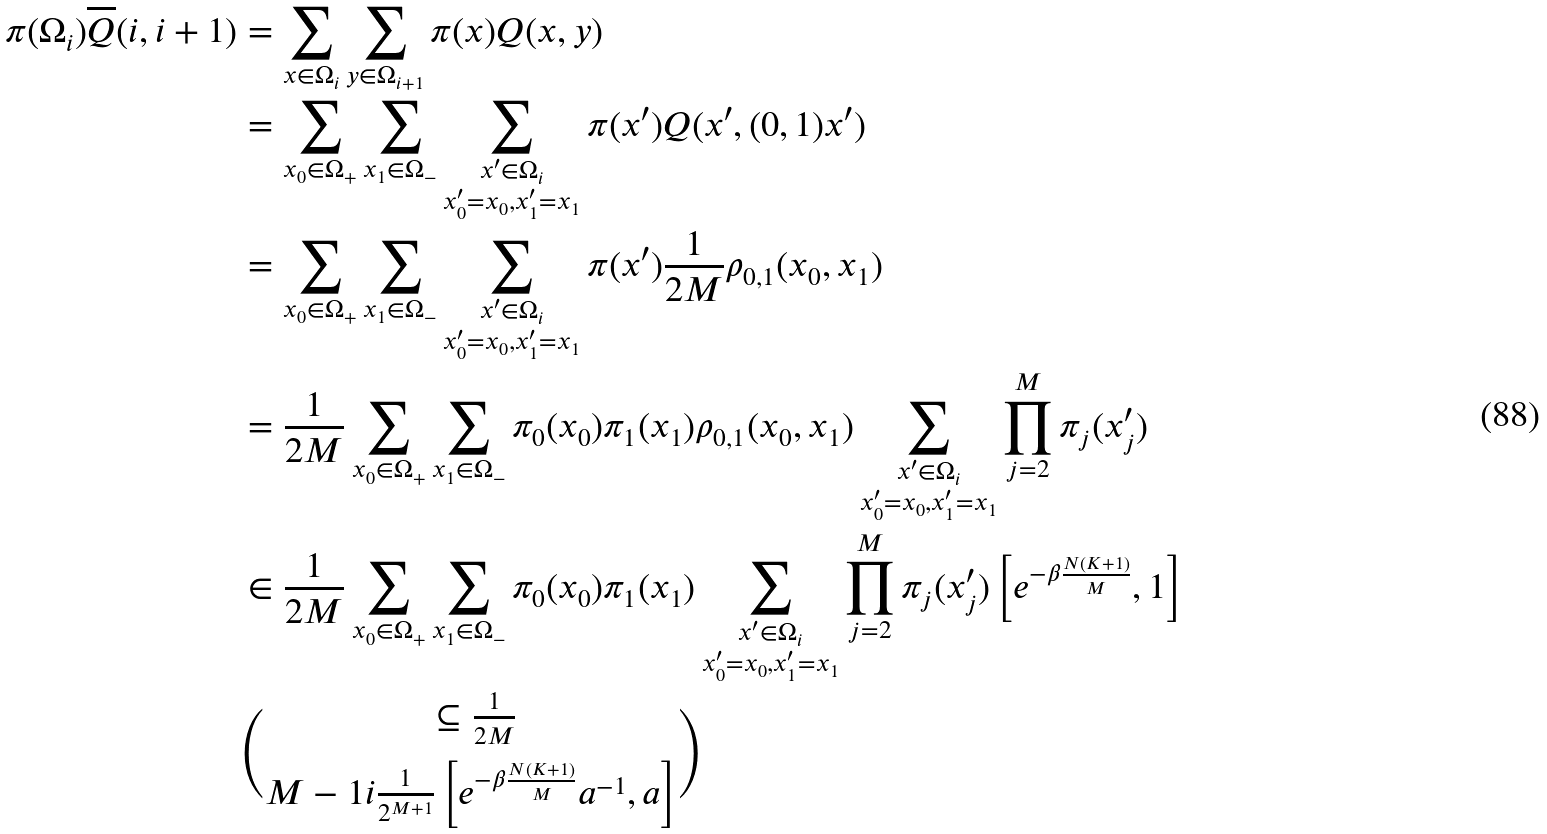Convert formula to latex. <formula><loc_0><loc_0><loc_500><loc_500>\pi ( \Omega _ { i } ) \overline { Q } ( i , i + 1 ) & = \sum _ { x \in \Omega _ { i } } \sum _ { y \in \Omega _ { i + 1 } } \pi ( x ) Q ( x , y ) \\ & = \sum _ { x _ { 0 } \in \Omega _ { + } } \sum _ { x _ { 1 } \in \Omega _ { - } } \sum _ { \substack { x ^ { \prime } \in \Omega _ { i } \\ x _ { 0 } ^ { \prime } = x _ { 0 } , x _ { 1 } ^ { \prime } = x _ { 1 } } } \pi ( x ^ { \prime } ) Q ( x ^ { \prime } , ( 0 , 1 ) x ^ { \prime } ) \\ & = \sum _ { x _ { 0 } \in \Omega _ { + } } \sum _ { x _ { 1 } \in \Omega _ { - } } \sum _ { \substack { x ^ { \prime } \in \Omega _ { i } \\ x _ { 0 } ^ { \prime } = x _ { 0 } , x _ { 1 } ^ { \prime } = x _ { 1 } } } \pi ( x ^ { \prime } ) \frac { 1 } { 2 M } \rho _ { 0 , 1 } ( x _ { 0 } , x _ { 1 } ) \\ & = \frac { 1 } { 2 M } \sum _ { x _ { 0 } \in \Omega _ { + } } \sum _ { x _ { 1 } \in \Omega _ { - } } \pi _ { 0 } ( x _ { 0 } ) \pi _ { 1 } ( x _ { 1 } ) \rho _ { 0 , 1 } ( x _ { 0 } , x _ { 1 } ) \sum _ { \substack { x ^ { \prime } \in \Omega _ { i } \\ x _ { 0 } ^ { \prime } = x _ { 0 } , x _ { 1 } ^ { \prime } = x _ { 1 } } } \prod _ { j = 2 } ^ { M } \pi _ { j } ( x ^ { \prime } _ { j } ) \\ & \in \frac { 1 } { 2 M } \sum _ { x _ { 0 } \in \Omega _ { + } } \sum _ { x _ { 1 } \in \Omega _ { - } } \pi _ { 0 } ( x _ { 0 } ) \pi _ { 1 } ( x _ { 1 } ) \sum _ { \substack { x ^ { \prime } \in \Omega _ { i } \\ x _ { 0 } ^ { \prime } = x _ { 0 } , x _ { 1 } ^ { \prime } = x _ { 1 } } } \prod _ { j = 2 } ^ { M } \pi _ { j } ( x ^ { \prime } _ { j } ) \left [ e ^ { - \beta \frac { N ( K + 1 ) } { M } } , 1 \right ] \\ & \subseteq \frac { 1 } { 2 M } \choose { M - 1 } { i } \frac { 1 } { 2 ^ { M + 1 } } \left [ e ^ { - \beta \frac { N ( K + 1 ) } { M } } a ^ { - 1 } , a \right ]</formula> 